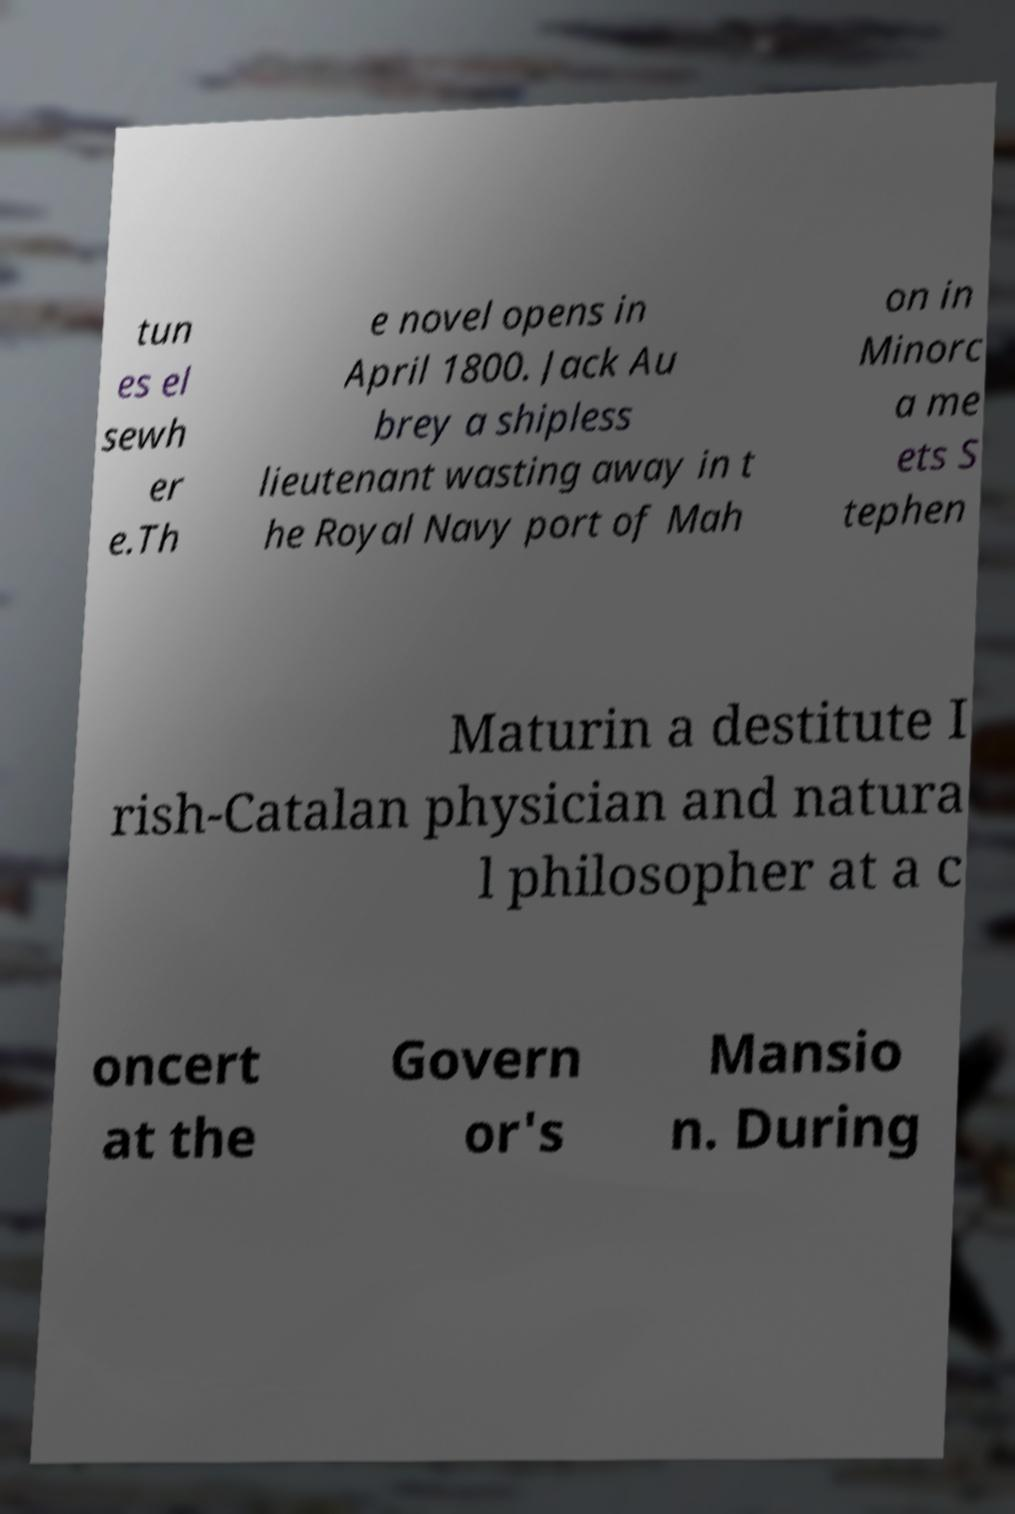Please identify and transcribe the text found in this image. tun es el sewh er e.Th e novel opens in April 1800. Jack Au brey a shipless lieutenant wasting away in t he Royal Navy port of Mah on in Minorc a me ets S tephen Maturin a destitute I rish-Catalan physician and natura l philosopher at a c oncert at the Govern or's Mansio n. During 